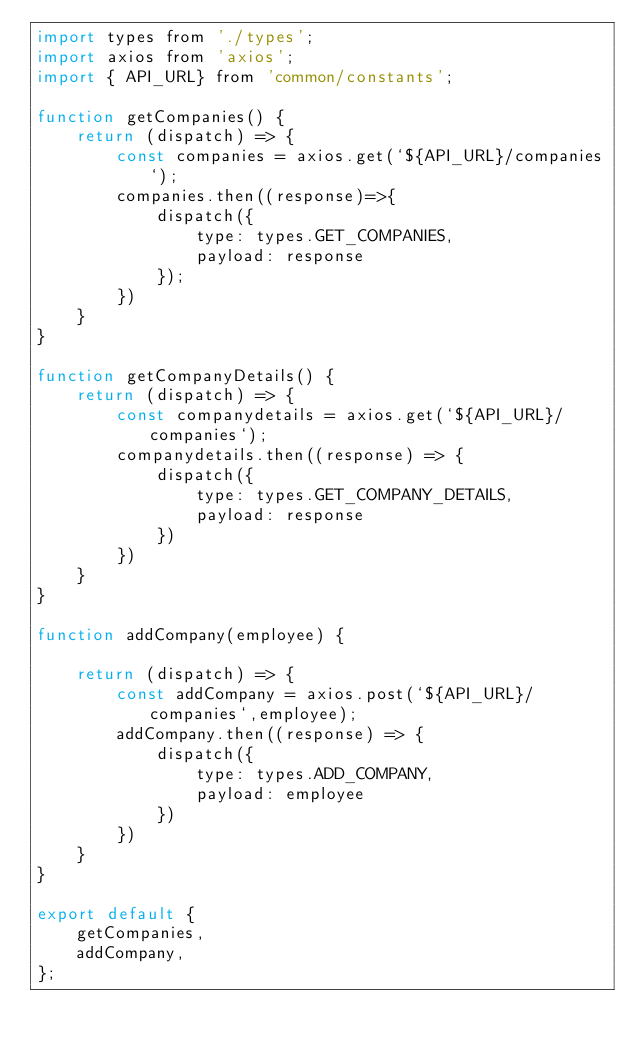Convert code to text. <code><loc_0><loc_0><loc_500><loc_500><_JavaScript_>import types from './types';
import axios from 'axios';
import { API_URL} from 'common/constants';

function getCompanies() {
    return (dispatch) => {
        const companies = axios.get(`${API_URL}/companies`);
        companies.then((response)=>{
            dispatch({
                type: types.GET_COMPANIES,
                payload: response
            });
        })
    }
}

function getCompanyDetails() {
    return (dispatch) => {
        const companydetails = axios.get(`${API_URL}/companies`);
        companydetails.then((response) => {
            dispatch({
                type: types.GET_COMPANY_DETAILS,
                payload: response
            })
        })
    }
}

function addCompany(employee) {
    
    return (dispatch) => {
        const addCompany = axios.post(`${API_URL}/companies`,employee);
        addCompany.then((response) => {
            dispatch({
                type: types.ADD_COMPANY,
                payload: employee
            })
        })
    }
}

export default {
    getCompanies,
    addCompany,
};</code> 